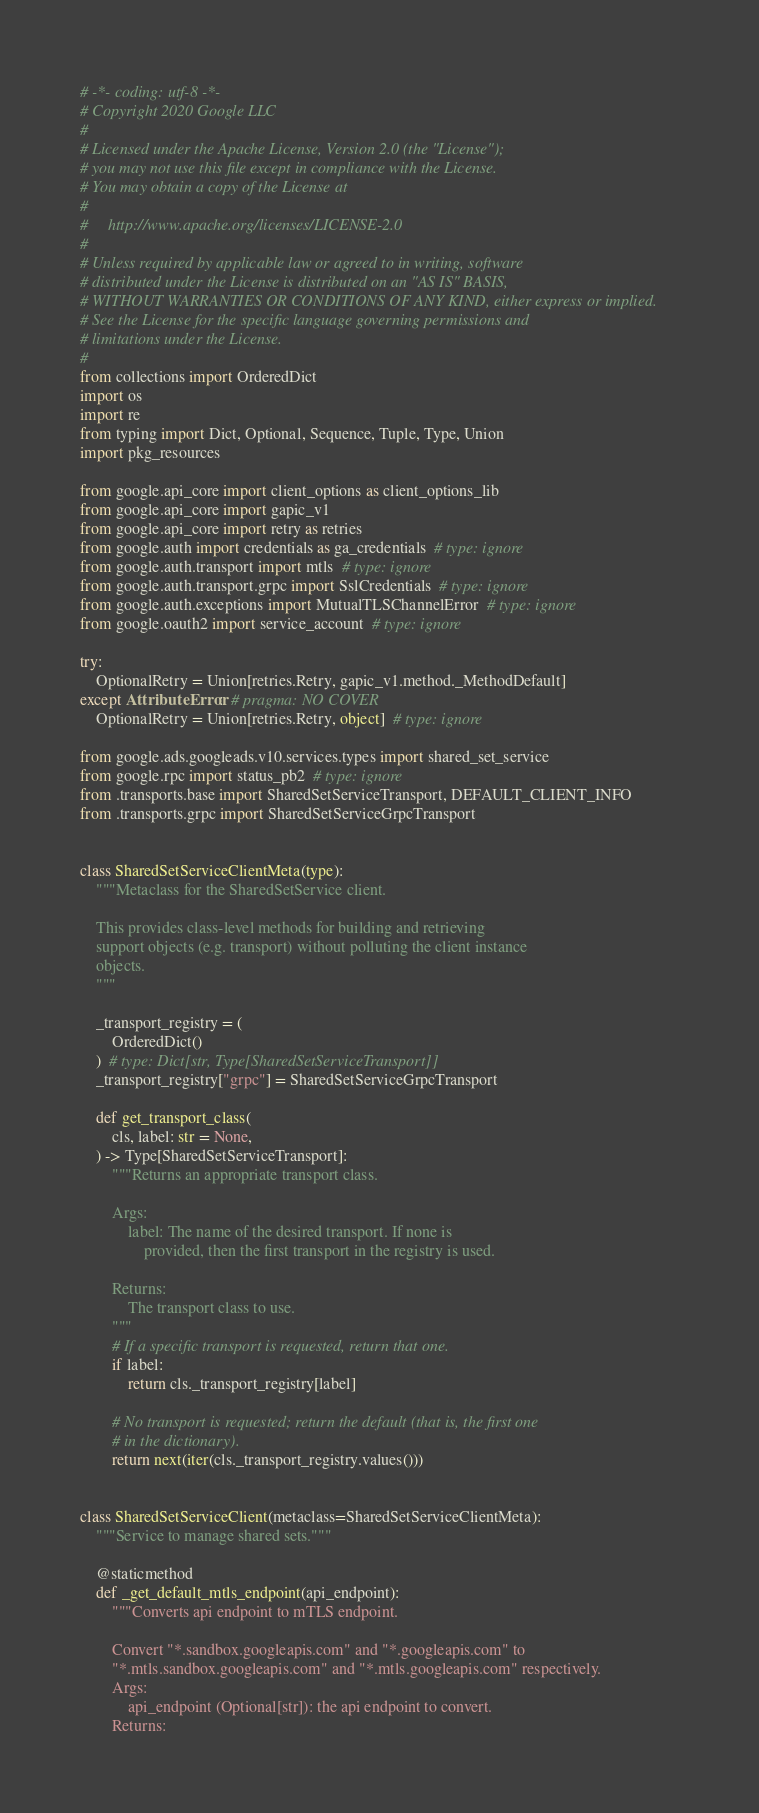<code> <loc_0><loc_0><loc_500><loc_500><_Python_># -*- coding: utf-8 -*-
# Copyright 2020 Google LLC
#
# Licensed under the Apache License, Version 2.0 (the "License");
# you may not use this file except in compliance with the License.
# You may obtain a copy of the License at
#
#     http://www.apache.org/licenses/LICENSE-2.0
#
# Unless required by applicable law or agreed to in writing, software
# distributed under the License is distributed on an "AS IS" BASIS,
# WITHOUT WARRANTIES OR CONDITIONS OF ANY KIND, either express or implied.
# See the License for the specific language governing permissions and
# limitations under the License.
#
from collections import OrderedDict
import os
import re
from typing import Dict, Optional, Sequence, Tuple, Type, Union
import pkg_resources

from google.api_core import client_options as client_options_lib
from google.api_core import gapic_v1
from google.api_core import retry as retries
from google.auth import credentials as ga_credentials  # type: ignore
from google.auth.transport import mtls  # type: ignore
from google.auth.transport.grpc import SslCredentials  # type: ignore
from google.auth.exceptions import MutualTLSChannelError  # type: ignore
from google.oauth2 import service_account  # type: ignore

try:
    OptionalRetry = Union[retries.Retry, gapic_v1.method._MethodDefault]
except AttributeError:  # pragma: NO COVER
    OptionalRetry = Union[retries.Retry, object]  # type: ignore

from google.ads.googleads.v10.services.types import shared_set_service
from google.rpc import status_pb2  # type: ignore
from .transports.base import SharedSetServiceTransport, DEFAULT_CLIENT_INFO
from .transports.grpc import SharedSetServiceGrpcTransport


class SharedSetServiceClientMeta(type):
    """Metaclass for the SharedSetService client.

    This provides class-level methods for building and retrieving
    support objects (e.g. transport) without polluting the client instance
    objects.
    """

    _transport_registry = (
        OrderedDict()
    )  # type: Dict[str, Type[SharedSetServiceTransport]]
    _transport_registry["grpc"] = SharedSetServiceGrpcTransport

    def get_transport_class(
        cls, label: str = None,
    ) -> Type[SharedSetServiceTransport]:
        """Returns an appropriate transport class.

        Args:
            label: The name of the desired transport. If none is
                provided, then the first transport in the registry is used.

        Returns:
            The transport class to use.
        """
        # If a specific transport is requested, return that one.
        if label:
            return cls._transport_registry[label]

        # No transport is requested; return the default (that is, the first one
        # in the dictionary).
        return next(iter(cls._transport_registry.values()))


class SharedSetServiceClient(metaclass=SharedSetServiceClientMeta):
    """Service to manage shared sets."""

    @staticmethod
    def _get_default_mtls_endpoint(api_endpoint):
        """Converts api endpoint to mTLS endpoint.

        Convert "*.sandbox.googleapis.com" and "*.googleapis.com" to
        "*.mtls.sandbox.googleapis.com" and "*.mtls.googleapis.com" respectively.
        Args:
            api_endpoint (Optional[str]): the api endpoint to convert.
        Returns:</code> 